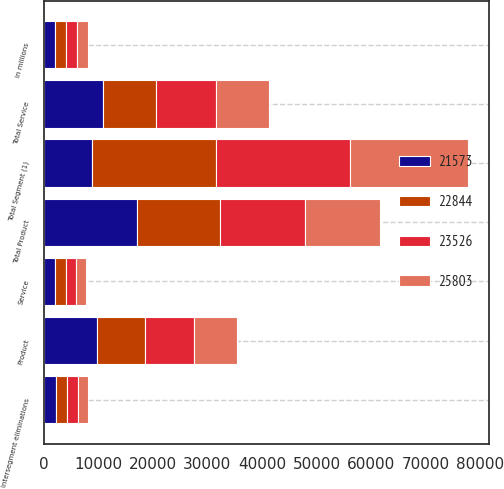Convert chart to OTSL. <chart><loc_0><loc_0><loc_500><loc_500><stacked_bar_chart><ecel><fcel>in millions<fcel>Product<fcel>Service<fcel>Total Product<fcel>Total Service<fcel>Intersegment eliminations<fcel>Total Segment (1)<nl><fcel>21573<fcel>2017<fcel>9841<fcel>2114<fcel>17140<fcel>10947<fcel>2284<fcel>8796<nl><fcel>22844<fcel>2017<fcel>8796<fcel>1900<fcel>15137<fcel>9714<fcel>2007<fcel>22844<nl><fcel>23526<fcel>2016<fcel>8868<fcel>1960<fcel>15659<fcel>10922<fcel>2073<fcel>24508<nl><fcel>25803<fcel>2016<fcel>7837<fcel>1755<fcel>13717<fcel>9671<fcel>1815<fcel>21573<nl></chart> 